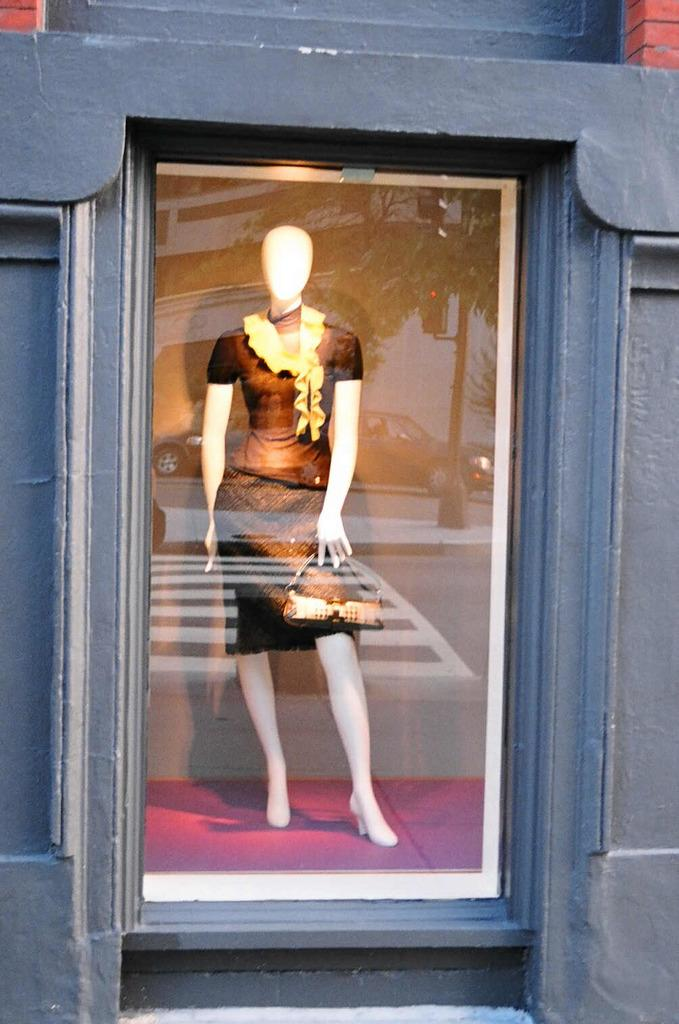What is the main subject of the image? There is a statue in the image. What is the statue wearing? The statue is wearing a black dress and skirt. Where is the statue located in the image? The statue is standing in a mirror box. Can you see a boy performing an operation on the statue in the image? No, there is no mention of a boy or an operation in the image. 